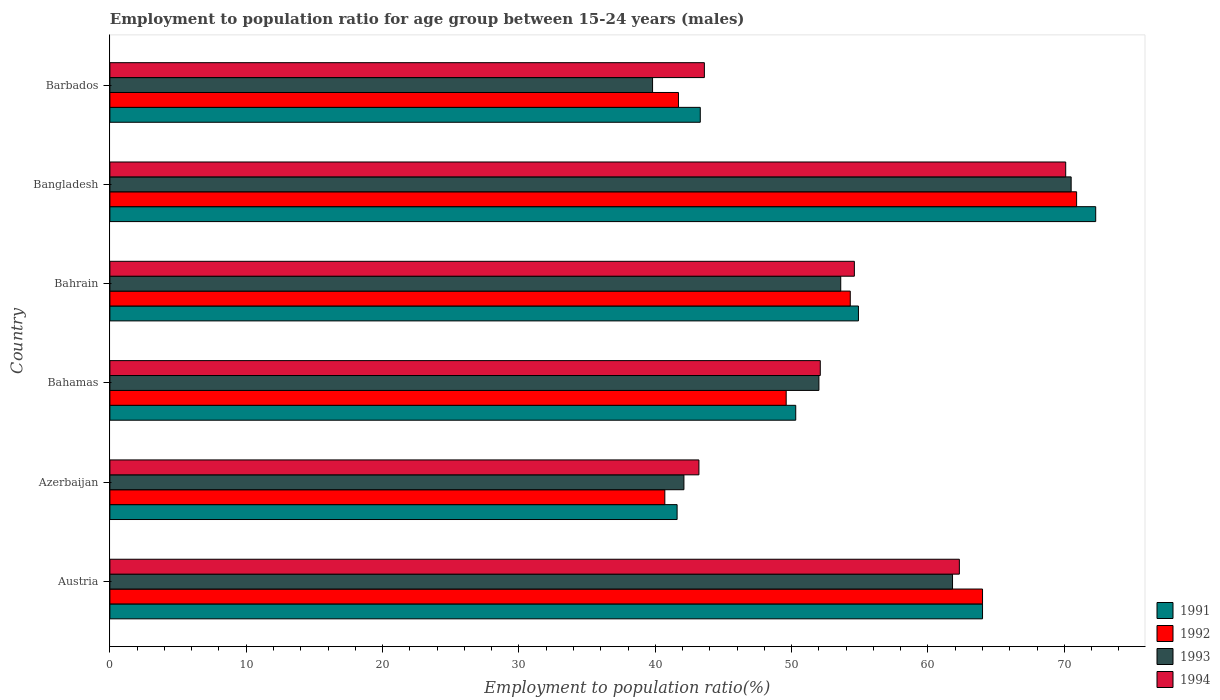How many different coloured bars are there?
Your response must be concise. 4. How many groups of bars are there?
Provide a short and direct response. 6. Are the number of bars per tick equal to the number of legend labels?
Provide a succinct answer. Yes. What is the label of the 3rd group of bars from the top?
Your answer should be very brief. Bahrain. In how many cases, is the number of bars for a given country not equal to the number of legend labels?
Your answer should be very brief. 0. What is the employment to population ratio in 1991 in Azerbaijan?
Your answer should be compact. 41.6. Across all countries, what is the maximum employment to population ratio in 1994?
Make the answer very short. 70.1. Across all countries, what is the minimum employment to population ratio in 1991?
Your answer should be compact. 41.6. In which country was the employment to population ratio in 1994 maximum?
Your answer should be very brief. Bangladesh. In which country was the employment to population ratio in 1992 minimum?
Offer a terse response. Azerbaijan. What is the total employment to population ratio in 1993 in the graph?
Offer a terse response. 319.8. What is the difference between the employment to population ratio in 1994 in Bahamas and that in Barbados?
Offer a terse response. 8.5. What is the difference between the employment to population ratio in 1994 in Bahrain and the employment to population ratio in 1991 in Barbados?
Your response must be concise. 11.3. What is the average employment to population ratio in 1993 per country?
Provide a succinct answer. 53.3. What is the difference between the employment to population ratio in 1993 and employment to population ratio in 1992 in Bahamas?
Your answer should be compact. 2.4. In how many countries, is the employment to population ratio in 1992 greater than 6 %?
Offer a terse response. 6. What is the ratio of the employment to population ratio in 1994 in Bahrain to that in Bangladesh?
Your response must be concise. 0.78. What is the difference between the highest and the second highest employment to population ratio in 1991?
Keep it short and to the point. 8.3. What is the difference between the highest and the lowest employment to population ratio in 1994?
Offer a very short reply. 26.9. Is the sum of the employment to population ratio in 1993 in Azerbaijan and Barbados greater than the maximum employment to population ratio in 1992 across all countries?
Ensure brevity in your answer.  Yes. Is it the case that in every country, the sum of the employment to population ratio in 1993 and employment to population ratio in 1992 is greater than the employment to population ratio in 1991?
Offer a very short reply. Yes. Are all the bars in the graph horizontal?
Ensure brevity in your answer.  Yes. How many countries are there in the graph?
Offer a terse response. 6. Does the graph contain any zero values?
Provide a short and direct response. No. Where does the legend appear in the graph?
Keep it short and to the point. Bottom right. How many legend labels are there?
Give a very brief answer. 4. What is the title of the graph?
Offer a very short reply. Employment to population ratio for age group between 15-24 years (males). Does "1991" appear as one of the legend labels in the graph?
Your answer should be compact. Yes. What is the Employment to population ratio(%) of 1991 in Austria?
Offer a terse response. 64. What is the Employment to population ratio(%) in 1992 in Austria?
Offer a terse response. 64. What is the Employment to population ratio(%) in 1993 in Austria?
Ensure brevity in your answer.  61.8. What is the Employment to population ratio(%) of 1994 in Austria?
Provide a succinct answer. 62.3. What is the Employment to population ratio(%) of 1991 in Azerbaijan?
Keep it short and to the point. 41.6. What is the Employment to population ratio(%) in 1992 in Azerbaijan?
Your response must be concise. 40.7. What is the Employment to population ratio(%) in 1993 in Azerbaijan?
Offer a terse response. 42.1. What is the Employment to population ratio(%) in 1994 in Azerbaijan?
Your answer should be very brief. 43.2. What is the Employment to population ratio(%) in 1991 in Bahamas?
Provide a short and direct response. 50.3. What is the Employment to population ratio(%) of 1992 in Bahamas?
Ensure brevity in your answer.  49.6. What is the Employment to population ratio(%) in 1993 in Bahamas?
Your response must be concise. 52. What is the Employment to population ratio(%) in 1994 in Bahamas?
Your answer should be very brief. 52.1. What is the Employment to population ratio(%) of 1991 in Bahrain?
Your response must be concise. 54.9. What is the Employment to population ratio(%) in 1992 in Bahrain?
Make the answer very short. 54.3. What is the Employment to population ratio(%) in 1993 in Bahrain?
Your answer should be very brief. 53.6. What is the Employment to population ratio(%) of 1994 in Bahrain?
Give a very brief answer. 54.6. What is the Employment to population ratio(%) of 1991 in Bangladesh?
Keep it short and to the point. 72.3. What is the Employment to population ratio(%) in 1992 in Bangladesh?
Offer a very short reply. 70.9. What is the Employment to population ratio(%) of 1993 in Bangladesh?
Offer a very short reply. 70.5. What is the Employment to population ratio(%) in 1994 in Bangladesh?
Provide a short and direct response. 70.1. What is the Employment to population ratio(%) of 1991 in Barbados?
Make the answer very short. 43.3. What is the Employment to population ratio(%) in 1992 in Barbados?
Your answer should be compact. 41.7. What is the Employment to population ratio(%) of 1993 in Barbados?
Your answer should be compact. 39.8. What is the Employment to population ratio(%) in 1994 in Barbados?
Provide a short and direct response. 43.6. Across all countries, what is the maximum Employment to population ratio(%) in 1991?
Give a very brief answer. 72.3. Across all countries, what is the maximum Employment to population ratio(%) of 1992?
Keep it short and to the point. 70.9. Across all countries, what is the maximum Employment to population ratio(%) in 1993?
Offer a terse response. 70.5. Across all countries, what is the maximum Employment to population ratio(%) in 1994?
Ensure brevity in your answer.  70.1. Across all countries, what is the minimum Employment to population ratio(%) of 1991?
Offer a terse response. 41.6. Across all countries, what is the minimum Employment to population ratio(%) in 1992?
Keep it short and to the point. 40.7. Across all countries, what is the minimum Employment to population ratio(%) of 1993?
Offer a very short reply. 39.8. Across all countries, what is the minimum Employment to population ratio(%) of 1994?
Offer a very short reply. 43.2. What is the total Employment to population ratio(%) in 1991 in the graph?
Your answer should be very brief. 326.4. What is the total Employment to population ratio(%) in 1992 in the graph?
Your response must be concise. 321.2. What is the total Employment to population ratio(%) in 1993 in the graph?
Offer a terse response. 319.8. What is the total Employment to population ratio(%) in 1994 in the graph?
Ensure brevity in your answer.  325.9. What is the difference between the Employment to population ratio(%) in 1991 in Austria and that in Azerbaijan?
Keep it short and to the point. 22.4. What is the difference between the Employment to population ratio(%) in 1992 in Austria and that in Azerbaijan?
Keep it short and to the point. 23.3. What is the difference between the Employment to population ratio(%) in 1993 in Austria and that in Azerbaijan?
Provide a succinct answer. 19.7. What is the difference between the Employment to population ratio(%) of 1994 in Austria and that in Azerbaijan?
Give a very brief answer. 19.1. What is the difference between the Employment to population ratio(%) of 1992 in Austria and that in Bahamas?
Your response must be concise. 14.4. What is the difference between the Employment to population ratio(%) in 1991 in Austria and that in Bahrain?
Your answer should be very brief. 9.1. What is the difference between the Employment to population ratio(%) of 1992 in Austria and that in Bahrain?
Provide a succinct answer. 9.7. What is the difference between the Employment to population ratio(%) of 1992 in Austria and that in Bangladesh?
Provide a succinct answer. -6.9. What is the difference between the Employment to population ratio(%) of 1991 in Austria and that in Barbados?
Keep it short and to the point. 20.7. What is the difference between the Employment to population ratio(%) of 1992 in Austria and that in Barbados?
Offer a terse response. 22.3. What is the difference between the Employment to population ratio(%) in 1993 in Austria and that in Barbados?
Ensure brevity in your answer.  22. What is the difference between the Employment to population ratio(%) of 1991 in Azerbaijan and that in Bahamas?
Make the answer very short. -8.7. What is the difference between the Employment to population ratio(%) of 1993 in Azerbaijan and that in Bahamas?
Offer a very short reply. -9.9. What is the difference between the Employment to population ratio(%) of 1993 in Azerbaijan and that in Bahrain?
Provide a short and direct response. -11.5. What is the difference between the Employment to population ratio(%) in 1991 in Azerbaijan and that in Bangladesh?
Give a very brief answer. -30.7. What is the difference between the Employment to population ratio(%) in 1992 in Azerbaijan and that in Bangladesh?
Make the answer very short. -30.2. What is the difference between the Employment to population ratio(%) of 1993 in Azerbaijan and that in Bangladesh?
Give a very brief answer. -28.4. What is the difference between the Employment to population ratio(%) of 1994 in Azerbaijan and that in Bangladesh?
Provide a succinct answer. -26.9. What is the difference between the Employment to population ratio(%) in 1993 in Azerbaijan and that in Barbados?
Keep it short and to the point. 2.3. What is the difference between the Employment to population ratio(%) of 1994 in Azerbaijan and that in Barbados?
Your answer should be compact. -0.4. What is the difference between the Employment to population ratio(%) of 1992 in Bahamas and that in Bahrain?
Provide a succinct answer. -4.7. What is the difference between the Employment to population ratio(%) of 1993 in Bahamas and that in Bahrain?
Ensure brevity in your answer.  -1.6. What is the difference between the Employment to population ratio(%) in 1992 in Bahamas and that in Bangladesh?
Ensure brevity in your answer.  -21.3. What is the difference between the Employment to population ratio(%) of 1993 in Bahamas and that in Bangladesh?
Offer a terse response. -18.5. What is the difference between the Employment to population ratio(%) of 1991 in Bahamas and that in Barbados?
Offer a terse response. 7. What is the difference between the Employment to population ratio(%) of 1994 in Bahamas and that in Barbados?
Your response must be concise. 8.5. What is the difference between the Employment to population ratio(%) of 1991 in Bahrain and that in Bangladesh?
Your answer should be compact. -17.4. What is the difference between the Employment to population ratio(%) in 1992 in Bahrain and that in Bangladesh?
Offer a terse response. -16.6. What is the difference between the Employment to population ratio(%) in 1993 in Bahrain and that in Bangladesh?
Offer a very short reply. -16.9. What is the difference between the Employment to population ratio(%) in 1994 in Bahrain and that in Bangladesh?
Provide a succinct answer. -15.5. What is the difference between the Employment to population ratio(%) in 1991 in Bahrain and that in Barbados?
Give a very brief answer. 11.6. What is the difference between the Employment to population ratio(%) in 1993 in Bahrain and that in Barbados?
Your response must be concise. 13.8. What is the difference between the Employment to population ratio(%) in 1994 in Bahrain and that in Barbados?
Provide a succinct answer. 11. What is the difference between the Employment to population ratio(%) of 1992 in Bangladesh and that in Barbados?
Provide a succinct answer. 29.2. What is the difference between the Employment to population ratio(%) in 1993 in Bangladesh and that in Barbados?
Provide a short and direct response. 30.7. What is the difference between the Employment to population ratio(%) of 1991 in Austria and the Employment to population ratio(%) of 1992 in Azerbaijan?
Give a very brief answer. 23.3. What is the difference between the Employment to population ratio(%) of 1991 in Austria and the Employment to population ratio(%) of 1993 in Azerbaijan?
Your response must be concise. 21.9. What is the difference between the Employment to population ratio(%) of 1991 in Austria and the Employment to population ratio(%) of 1994 in Azerbaijan?
Ensure brevity in your answer.  20.8. What is the difference between the Employment to population ratio(%) of 1992 in Austria and the Employment to population ratio(%) of 1993 in Azerbaijan?
Provide a succinct answer. 21.9. What is the difference between the Employment to population ratio(%) in 1992 in Austria and the Employment to population ratio(%) in 1994 in Azerbaijan?
Give a very brief answer. 20.8. What is the difference between the Employment to population ratio(%) in 1993 in Austria and the Employment to population ratio(%) in 1994 in Azerbaijan?
Ensure brevity in your answer.  18.6. What is the difference between the Employment to population ratio(%) of 1992 in Austria and the Employment to population ratio(%) of 1993 in Bahamas?
Your response must be concise. 12. What is the difference between the Employment to population ratio(%) in 1992 in Austria and the Employment to population ratio(%) in 1994 in Bahamas?
Keep it short and to the point. 11.9. What is the difference between the Employment to population ratio(%) of 1993 in Austria and the Employment to population ratio(%) of 1994 in Bahamas?
Your answer should be very brief. 9.7. What is the difference between the Employment to population ratio(%) in 1991 in Austria and the Employment to population ratio(%) in 1992 in Bahrain?
Your response must be concise. 9.7. What is the difference between the Employment to population ratio(%) of 1992 in Austria and the Employment to population ratio(%) of 1993 in Bahrain?
Ensure brevity in your answer.  10.4. What is the difference between the Employment to population ratio(%) of 1993 in Austria and the Employment to population ratio(%) of 1994 in Bahrain?
Provide a short and direct response. 7.2. What is the difference between the Employment to population ratio(%) in 1991 in Austria and the Employment to population ratio(%) in 1992 in Bangladesh?
Give a very brief answer. -6.9. What is the difference between the Employment to population ratio(%) of 1991 in Austria and the Employment to population ratio(%) of 1994 in Bangladesh?
Give a very brief answer. -6.1. What is the difference between the Employment to population ratio(%) in 1991 in Austria and the Employment to population ratio(%) in 1992 in Barbados?
Make the answer very short. 22.3. What is the difference between the Employment to population ratio(%) of 1991 in Austria and the Employment to population ratio(%) of 1993 in Barbados?
Offer a very short reply. 24.2. What is the difference between the Employment to population ratio(%) of 1991 in Austria and the Employment to population ratio(%) of 1994 in Barbados?
Offer a terse response. 20.4. What is the difference between the Employment to population ratio(%) in 1992 in Austria and the Employment to population ratio(%) in 1993 in Barbados?
Make the answer very short. 24.2. What is the difference between the Employment to population ratio(%) of 1992 in Austria and the Employment to population ratio(%) of 1994 in Barbados?
Offer a very short reply. 20.4. What is the difference between the Employment to population ratio(%) of 1991 in Azerbaijan and the Employment to population ratio(%) of 1993 in Bahamas?
Your answer should be very brief. -10.4. What is the difference between the Employment to population ratio(%) in 1992 in Azerbaijan and the Employment to population ratio(%) in 1993 in Bahamas?
Offer a very short reply. -11.3. What is the difference between the Employment to population ratio(%) of 1992 in Azerbaijan and the Employment to population ratio(%) of 1994 in Bahamas?
Give a very brief answer. -11.4. What is the difference between the Employment to population ratio(%) of 1993 in Azerbaijan and the Employment to population ratio(%) of 1994 in Bahamas?
Give a very brief answer. -10. What is the difference between the Employment to population ratio(%) of 1991 in Azerbaijan and the Employment to population ratio(%) of 1994 in Bahrain?
Offer a very short reply. -13. What is the difference between the Employment to population ratio(%) in 1993 in Azerbaijan and the Employment to population ratio(%) in 1994 in Bahrain?
Keep it short and to the point. -12.5. What is the difference between the Employment to population ratio(%) in 1991 in Azerbaijan and the Employment to population ratio(%) in 1992 in Bangladesh?
Give a very brief answer. -29.3. What is the difference between the Employment to population ratio(%) in 1991 in Azerbaijan and the Employment to population ratio(%) in 1993 in Bangladesh?
Your answer should be very brief. -28.9. What is the difference between the Employment to population ratio(%) in 1991 in Azerbaijan and the Employment to population ratio(%) in 1994 in Bangladesh?
Offer a terse response. -28.5. What is the difference between the Employment to population ratio(%) of 1992 in Azerbaijan and the Employment to population ratio(%) of 1993 in Bangladesh?
Your answer should be very brief. -29.8. What is the difference between the Employment to population ratio(%) in 1992 in Azerbaijan and the Employment to population ratio(%) in 1994 in Bangladesh?
Your response must be concise. -29.4. What is the difference between the Employment to population ratio(%) in 1991 in Azerbaijan and the Employment to population ratio(%) in 1992 in Barbados?
Keep it short and to the point. -0.1. What is the difference between the Employment to population ratio(%) in 1991 in Azerbaijan and the Employment to population ratio(%) in 1993 in Barbados?
Ensure brevity in your answer.  1.8. What is the difference between the Employment to population ratio(%) of 1991 in Azerbaijan and the Employment to population ratio(%) of 1994 in Barbados?
Provide a short and direct response. -2. What is the difference between the Employment to population ratio(%) in 1991 in Bahamas and the Employment to population ratio(%) in 1993 in Bahrain?
Keep it short and to the point. -3.3. What is the difference between the Employment to population ratio(%) in 1991 in Bahamas and the Employment to population ratio(%) in 1994 in Bahrain?
Make the answer very short. -4.3. What is the difference between the Employment to population ratio(%) of 1992 in Bahamas and the Employment to population ratio(%) of 1993 in Bahrain?
Make the answer very short. -4. What is the difference between the Employment to population ratio(%) in 1991 in Bahamas and the Employment to population ratio(%) in 1992 in Bangladesh?
Offer a terse response. -20.6. What is the difference between the Employment to population ratio(%) in 1991 in Bahamas and the Employment to population ratio(%) in 1993 in Bangladesh?
Ensure brevity in your answer.  -20.2. What is the difference between the Employment to population ratio(%) in 1991 in Bahamas and the Employment to population ratio(%) in 1994 in Bangladesh?
Make the answer very short. -19.8. What is the difference between the Employment to population ratio(%) in 1992 in Bahamas and the Employment to population ratio(%) in 1993 in Bangladesh?
Provide a succinct answer. -20.9. What is the difference between the Employment to population ratio(%) of 1992 in Bahamas and the Employment to population ratio(%) of 1994 in Bangladesh?
Keep it short and to the point. -20.5. What is the difference between the Employment to population ratio(%) of 1993 in Bahamas and the Employment to population ratio(%) of 1994 in Bangladesh?
Your answer should be very brief. -18.1. What is the difference between the Employment to population ratio(%) of 1991 in Bahamas and the Employment to population ratio(%) of 1992 in Barbados?
Keep it short and to the point. 8.6. What is the difference between the Employment to population ratio(%) of 1991 in Bahamas and the Employment to population ratio(%) of 1993 in Barbados?
Provide a short and direct response. 10.5. What is the difference between the Employment to population ratio(%) in 1992 in Bahamas and the Employment to population ratio(%) in 1994 in Barbados?
Your answer should be very brief. 6. What is the difference between the Employment to population ratio(%) of 1991 in Bahrain and the Employment to population ratio(%) of 1993 in Bangladesh?
Make the answer very short. -15.6. What is the difference between the Employment to population ratio(%) of 1991 in Bahrain and the Employment to population ratio(%) of 1994 in Bangladesh?
Offer a very short reply. -15.2. What is the difference between the Employment to population ratio(%) of 1992 in Bahrain and the Employment to population ratio(%) of 1993 in Bangladesh?
Offer a terse response. -16.2. What is the difference between the Employment to population ratio(%) of 1992 in Bahrain and the Employment to population ratio(%) of 1994 in Bangladesh?
Your answer should be compact. -15.8. What is the difference between the Employment to population ratio(%) in 1993 in Bahrain and the Employment to population ratio(%) in 1994 in Bangladesh?
Your answer should be compact. -16.5. What is the difference between the Employment to population ratio(%) of 1991 in Bahrain and the Employment to population ratio(%) of 1994 in Barbados?
Provide a short and direct response. 11.3. What is the difference between the Employment to population ratio(%) in 1992 in Bahrain and the Employment to population ratio(%) in 1993 in Barbados?
Give a very brief answer. 14.5. What is the difference between the Employment to population ratio(%) in 1991 in Bangladesh and the Employment to population ratio(%) in 1992 in Barbados?
Ensure brevity in your answer.  30.6. What is the difference between the Employment to population ratio(%) in 1991 in Bangladesh and the Employment to population ratio(%) in 1993 in Barbados?
Make the answer very short. 32.5. What is the difference between the Employment to population ratio(%) in 1991 in Bangladesh and the Employment to population ratio(%) in 1994 in Barbados?
Ensure brevity in your answer.  28.7. What is the difference between the Employment to population ratio(%) in 1992 in Bangladesh and the Employment to population ratio(%) in 1993 in Barbados?
Provide a succinct answer. 31.1. What is the difference between the Employment to population ratio(%) in 1992 in Bangladesh and the Employment to population ratio(%) in 1994 in Barbados?
Provide a succinct answer. 27.3. What is the difference between the Employment to population ratio(%) in 1993 in Bangladesh and the Employment to population ratio(%) in 1994 in Barbados?
Provide a succinct answer. 26.9. What is the average Employment to population ratio(%) in 1991 per country?
Keep it short and to the point. 54.4. What is the average Employment to population ratio(%) of 1992 per country?
Your response must be concise. 53.53. What is the average Employment to population ratio(%) of 1993 per country?
Make the answer very short. 53.3. What is the average Employment to population ratio(%) in 1994 per country?
Your answer should be very brief. 54.32. What is the difference between the Employment to population ratio(%) of 1993 and Employment to population ratio(%) of 1994 in Austria?
Offer a very short reply. -0.5. What is the difference between the Employment to population ratio(%) of 1991 and Employment to population ratio(%) of 1992 in Azerbaijan?
Provide a succinct answer. 0.9. What is the difference between the Employment to population ratio(%) in 1991 and Employment to population ratio(%) in 1993 in Azerbaijan?
Ensure brevity in your answer.  -0.5. What is the difference between the Employment to population ratio(%) in 1993 and Employment to population ratio(%) in 1994 in Azerbaijan?
Ensure brevity in your answer.  -1.1. What is the difference between the Employment to population ratio(%) in 1992 and Employment to population ratio(%) in 1994 in Bahamas?
Provide a short and direct response. -2.5. What is the difference between the Employment to population ratio(%) of 1992 and Employment to population ratio(%) of 1993 in Bahrain?
Provide a succinct answer. 0.7. What is the difference between the Employment to population ratio(%) in 1992 and Employment to population ratio(%) in 1994 in Bahrain?
Give a very brief answer. -0.3. What is the difference between the Employment to population ratio(%) in 1993 and Employment to population ratio(%) in 1994 in Bahrain?
Your response must be concise. -1. What is the difference between the Employment to population ratio(%) of 1991 and Employment to population ratio(%) of 1992 in Bangladesh?
Offer a terse response. 1.4. What is the difference between the Employment to population ratio(%) of 1992 and Employment to population ratio(%) of 1993 in Bangladesh?
Provide a short and direct response. 0.4. What is the difference between the Employment to population ratio(%) of 1992 and Employment to population ratio(%) of 1994 in Bangladesh?
Keep it short and to the point. 0.8. What is the difference between the Employment to population ratio(%) of 1991 and Employment to population ratio(%) of 1992 in Barbados?
Offer a very short reply. 1.6. What is the difference between the Employment to population ratio(%) in 1991 and Employment to population ratio(%) in 1994 in Barbados?
Offer a very short reply. -0.3. What is the difference between the Employment to population ratio(%) in 1992 and Employment to population ratio(%) in 1993 in Barbados?
Provide a succinct answer. 1.9. What is the ratio of the Employment to population ratio(%) in 1991 in Austria to that in Azerbaijan?
Provide a short and direct response. 1.54. What is the ratio of the Employment to population ratio(%) of 1992 in Austria to that in Azerbaijan?
Make the answer very short. 1.57. What is the ratio of the Employment to population ratio(%) in 1993 in Austria to that in Azerbaijan?
Ensure brevity in your answer.  1.47. What is the ratio of the Employment to population ratio(%) of 1994 in Austria to that in Azerbaijan?
Make the answer very short. 1.44. What is the ratio of the Employment to population ratio(%) of 1991 in Austria to that in Bahamas?
Offer a terse response. 1.27. What is the ratio of the Employment to population ratio(%) in 1992 in Austria to that in Bahamas?
Ensure brevity in your answer.  1.29. What is the ratio of the Employment to population ratio(%) in 1993 in Austria to that in Bahamas?
Provide a succinct answer. 1.19. What is the ratio of the Employment to population ratio(%) of 1994 in Austria to that in Bahamas?
Your answer should be compact. 1.2. What is the ratio of the Employment to population ratio(%) of 1991 in Austria to that in Bahrain?
Keep it short and to the point. 1.17. What is the ratio of the Employment to population ratio(%) in 1992 in Austria to that in Bahrain?
Your answer should be very brief. 1.18. What is the ratio of the Employment to population ratio(%) in 1993 in Austria to that in Bahrain?
Provide a short and direct response. 1.15. What is the ratio of the Employment to population ratio(%) in 1994 in Austria to that in Bahrain?
Your answer should be very brief. 1.14. What is the ratio of the Employment to population ratio(%) of 1991 in Austria to that in Bangladesh?
Your answer should be very brief. 0.89. What is the ratio of the Employment to population ratio(%) in 1992 in Austria to that in Bangladesh?
Your answer should be compact. 0.9. What is the ratio of the Employment to population ratio(%) of 1993 in Austria to that in Bangladesh?
Provide a short and direct response. 0.88. What is the ratio of the Employment to population ratio(%) of 1994 in Austria to that in Bangladesh?
Your answer should be compact. 0.89. What is the ratio of the Employment to population ratio(%) in 1991 in Austria to that in Barbados?
Your answer should be compact. 1.48. What is the ratio of the Employment to population ratio(%) in 1992 in Austria to that in Barbados?
Give a very brief answer. 1.53. What is the ratio of the Employment to population ratio(%) of 1993 in Austria to that in Barbados?
Provide a short and direct response. 1.55. What is the ratio of the Employment to population ratio(%) of 1994 in Austria to that in Barbados?
Your answer should be very brief. 1.43. What is the ratio of the Employment to population ratio(%) of 1991 in Azerbaijan to that in Bahamas?
Ensure brevity in your answer.  0.83. What is the ratio of the Employment to population ratio(%) of 1992 in Azerbaijan to that in Bahamas?
Ensure brevity in your answer.  0.82. What is the ratio of the Employment to population ratio(%) of 1993 in Azerbaijan to that in Bahamas?
Provide a short and direct response. 0.81. What is the ratio of the Employment to population ratio(%) of 1994 in Azerbaijan to that in Bahamas?
Ensure brevity in your answer.  0.83. What is the ratio of the Employment to population ratio(%) of 1991 in Azerbaijan to that in Bahrain?
Offer a terse response. 0.76. What is the ratio of the Employment to population ratio(%) in 1992 in Azerbaijan to that in Bahrain?
Provide a succinct answer. 0.75. What is the ratio of the Employment to population ratio(%) in 1993 in Azerbaijan to that in Bahrain?
Give a very brief answer. 0.79. What is the ratio of the Employment to population ratio(%) in 1994 in Azerbaijan to that in Bahrain?
Your answer should be very brief. 0.79. What is the ratio of the Employment to population ratio(%) of 1991 in Azerbaijan to that in Bangladesh?
Keep it short and to the point. 0.58. What is the ratio of the Employment to population ratio(%) in 1992 in Azerbaijan to that in Bangladesh?
Give a very brief answer. 0.57. What is the ratio of the Employment to population ratio(%) of 1993 in Azerbaijan to that in Bangladesh?
Provide a succinct answer. 0.6. What is the ratio of the Employment to population ratio(%) of 1994 in Azerbaijan to that in Bangladesh?
Offer a terse response. 0.62. What is the ratio of the Employment to population ratio(%) of 1991 in Azerbaijan to that in Barbados?
Offer a very short reply. 0.96. What is the ratio of the Employment to population ratio(%) of 1993 in Azerbaijan to that in Barbados?
Your answer should be very brief. 1.06. What is the ratio of the Employment to population ratio(%) of 1991 in Bahamas to that in Bahrain?
Keep it short and to the point. 0.92. What is the ratio of the Employment to population ratio(%) of 1992 in Bahamas to that in Bahrain?
Your response must be concise. 0.91. What is the ratio of the Employment to population ratio(%) of 1993 in Bahamas to that in Bahrain?
Make the answer very short. 0.97. What is the ratio of the Employment to population ratio(%) of 1994 in Bahamas to that in Bahrain?
Ensure brevity in your answer.  0.95. What is the ratio of the Employment to population ratio(%) of 1991 in Bahamas to that in Bangladesh?
Offer a very short reply. 0.7. What is the ratio of the Employment to population ratio(%) in 1992 in Bahamas to that in Bangladesh?
Give a very brief answer. 0.7. What is the ratio of the Employment to population ratio(%) in 1993 in Bahamas to that in Bangladesh?
Provide a succinct answer. 0.74. What is the ratio of the Employment to population ratio(%) in 1994 in Bahamas to that in Bangladesh?
Your response must be concise. 0.74. What is the ratio of the Employment to population ratio(%) of 1991 in Bahamas to that in Barbados?
Your answer should be compact. 1.16. What is the ratio of the Employment to population ratio(%) in 1992 in Bahamas to that in Barbados?
Provide a short and direct response. 1.19. What is the ratio of the Employment to population ratio(%) of 1993 in Bahamas to that in Barbados?
Give a very brief answer. 1.31. What is the ratio of the Employment to population ratio(%) in 1994 in Bahamas to that in Barbados?
Your answer should be compact. 1.2. What is the ratio of the Employment to population ratio(%) in 1991 in Bahrain to that in Bangladesh?
Keep it short and to the point. 0.76. What is the ratio of the Employment to population ratio(%) in 1992 in Bahrain to that in Bangladesh?
Your answer should be compact. 0.77. What is the ratio of the Employment to population ratio(%) in 1993 in Bahrain to that in Bangladesh?
Provide a succinct answer. 0.76. What is the ratio of the Employment to population ratio(%) in 1994 in Bahrain to that in Bangladesh?
Provide a succinct answer. 0.78. What is the ratio of the Employment to population ratio(%) of 1991 in Bahrain to that in Barbados?
Your response must be concise. 1.27. What is the ratio of the Employment to population ratio(%) of 1992 in Bahrain to that in Barbados?
Your answer should be very brief. 1.3. What is the ratio of the Employment to population ratio(%) in 1993 in Bahrain to that in Barbados?
Give a very brief answer. 1.35. What is the ratio of the Employment to population ratio(%) of 1994 in Bahrain to that in Barbados?
Your answer should be very brief. 1.25. What is the ratio of the Employment to population ratio(%) of 1991 in Bangladesh to that in Barbados?
Give a very brief answer. 1.67. What is the ratio of the Employment to population ratio(%) in 1992 in Bangladesh to that in Barbados?
Your response must be concise. 1.7. What is the ratio of the Employment to population ratio(%) of 1993 in Bangladesh to that in Barbados?
Provide a short and direct response. 1.77. What is the ratio of the Employment to population ratio(%) of 1994 in Bangladesh to that in Barbados?
Provide a succinct answer. 1.61. What is the difference between the highest and the second highest Employment to population ratio(%) of 1994?
Your answer should be compact. 7.8. What is the difference between the highest and the lowest Employment to population ratio(%) of 1991?
Make the answer very short. 30.7. What is the difference between the highest and the lowest Employment to population ratio(%) in 1992?
Keep it short and to the point. 30.2. What is the difference between the highest and the lowest Employment to population ratio(%) in 1993?
Offer a terse response. 30.7. What is the difference between the highest and the lowest Employment to population ratio(%) of 1994?
Your answer should be compact. 26.9. 